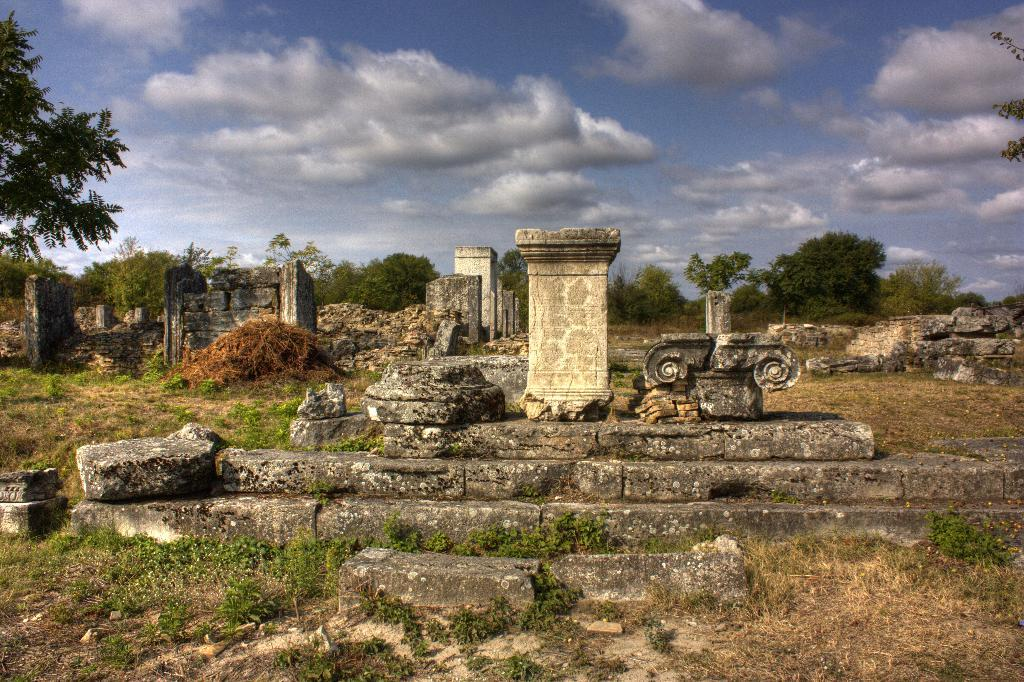What type of vegetation can be seen in the image? There are trees, plants, and grass in the image. What architectural features are present in the image? There are pillars and stairs in the image. What natural elements can be found in the image? There are rocks and twigs in the image. What is the condition of the sky in the background of the image? The background of the image includes a cloudy sky. Can you tell me how many dimes are scattered among the rocks in the image? There are no dimes present in the image; it features trees, pillars, stairs, rocks, plants, grass, twigs, and a cloudy sky. 